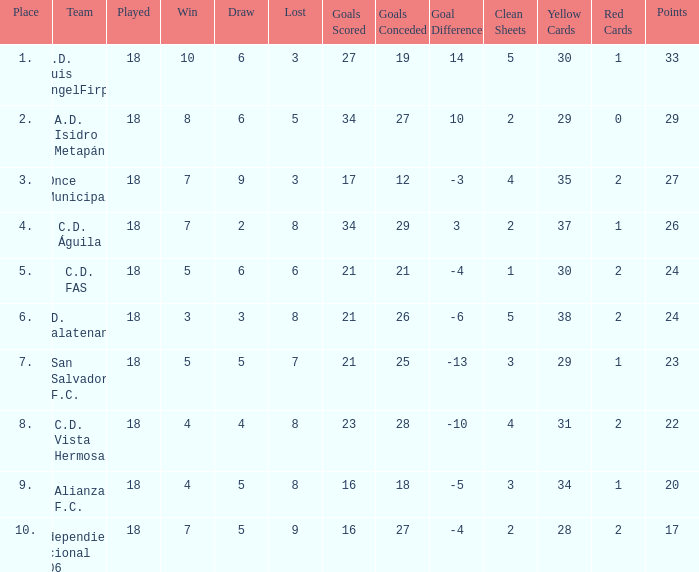Could you help me parse every detail presented in this table? {'header': ['Place', 'Team', 'Played', 'Win', 'Draw', 'Lost', 'Goals Scored', 'Goals Conceded', 'Goal Difference', 'Clean Sheets', 'Yellow Cards', 'Red Cards', 'Points'], 'rows': [['1.', 'C.D. Luis AngelFirpo', '18', '10', '6', '3', '27', '19', '14', '5', '30', '1', '33'], ['2.', 'A.D. Isidro Metapán', '18', '8', '6', '5', '34', '27', '10', '2', '29', '0', '29'], ['3.', 'Once Municipal', '18', '7', '9', '3', '17', '12', '-3', '4', '35', '2', '27'], ['4.', 'C.D. Águila', '18', '7', '2', '8', '34', '29', '3', '2', '37', '1', '26'], ['5.', 'C.D. FAS', '18', '5', '6', '6', '21', '21', '-4', '1', '30', '2', '24'], ['6.', 'C.D. Chalatenango', '18', '3', '3', '8', '21', '26', '-6', '5', '38', '2', '24'], ['7.', 'San Salvador F.C.', '18', '5', '5', '7', '21', '25', '-13', '3', '29', '1', '23'], ['8.', 'C.D. Vista Hermosa', '18', '4', '4', '8', '23', '28', '-10', '4', '31', '2', '22'], ['9.', 'Alianza F.C.', '18', '4', '5', '8', '16', '18', '-5', '3', '34', '1', '20'], ['10.', 'Independiente Nacional 1906', '18', '7', '5', '9', '16', '27', '-4', '2', '28', '2', '17']]} What is the lowest amount of goals scored that has more than 19 goal conceded and played less than 18? None. 